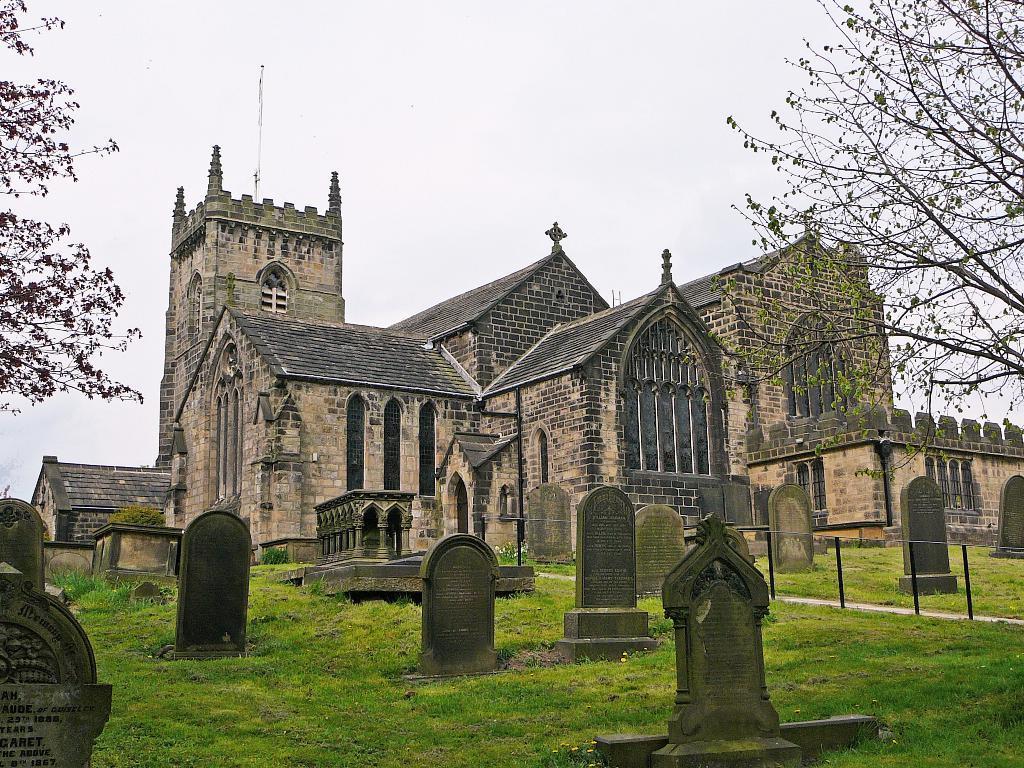How would you summarize this image in a sentence or two? In the foreground of the picture there are gravestones and trees. In the middle of the picture there is a church. At the top there is sky. In the foreground we can see glass also. 